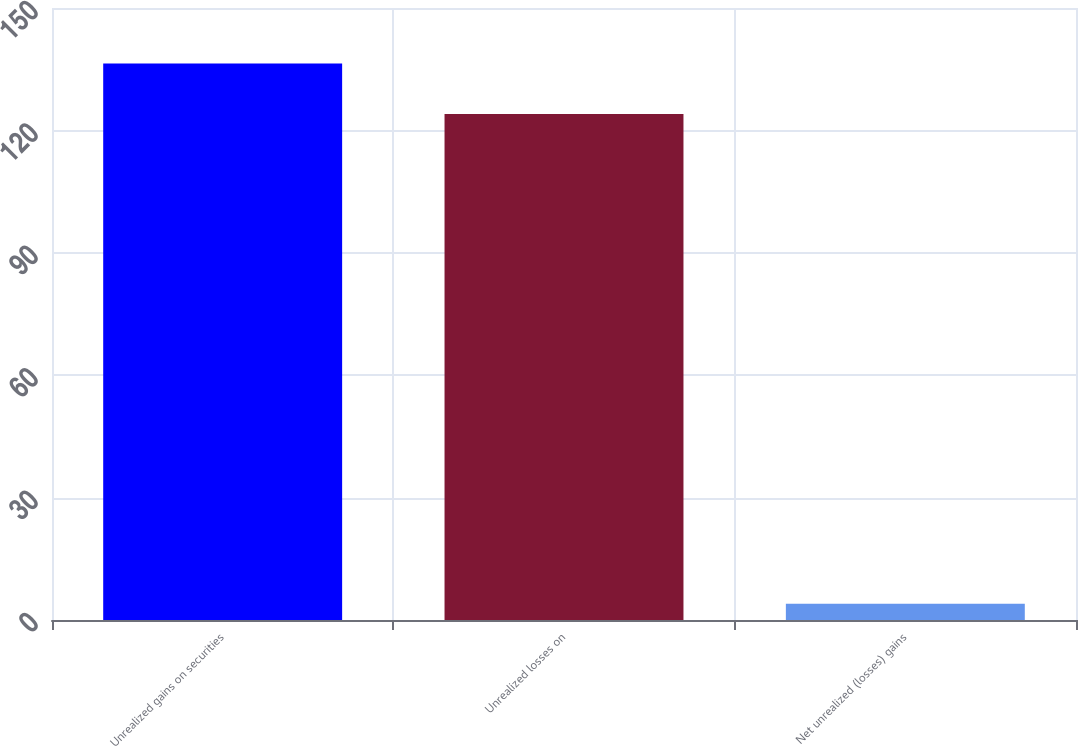Convert chart to OTSL. <chart><loc_0><loc_0><loc_500><loc_500><bar_chart><fcel>Unrealized gains on securities<fcel>Unrealized losses on<fcel>Net unrealized (losses) gains<nl><fcel>136.4<fcel>124<fcel>4<nl></chart> 